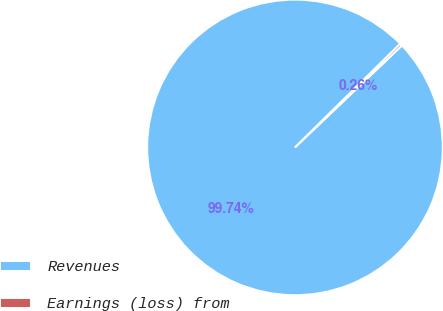Convert chart. <chart><loc_0><loc_0><loc_500><loc_500><pie_chart><fcel>Revenues<fcel>Earnings (loss) from<nl><fcel>99.74%<fcel>0.26%<nl></chart> 